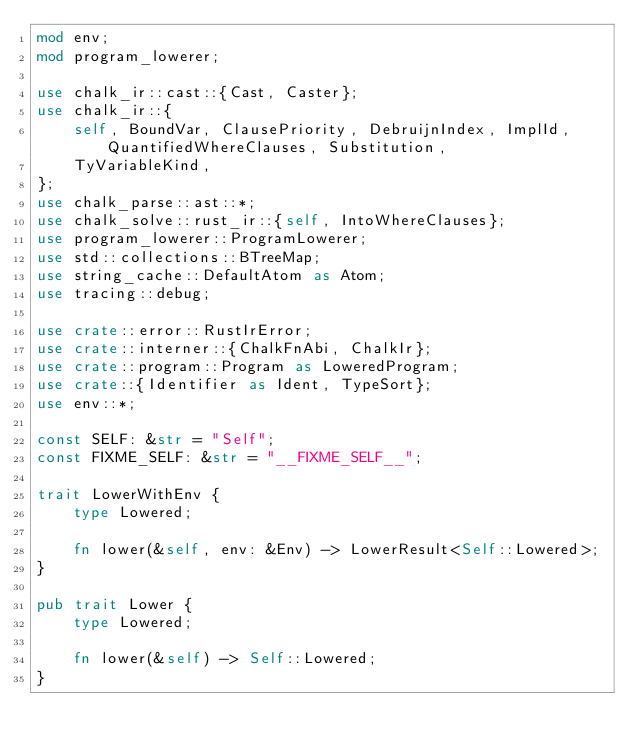Convert code to text. <code><loc_0><loc_0><loc_500><loc_500><_Rust_>mod env;
mod program_lowerer;

use chalk_ir::cast::{Cast, Caster};
use chalk_ir::{
    self, BoundVar, ClausePriority, DebruijnIndex, ImplId, QuantifiedWhereClauses, Substitution,
    TyVariableKind,
};
use chalk_parse::ast::*;
use chalk_solve::rust_ir::{self, IntoWhereClauses};
use program_lowerer::ProgramLowerer;
use std::collections::BTreeMap;
use string_cache::DefaultAtom as Atom;
use tracing::debug;

use crate::error::RustIrError;
use crate::interner::{ChalkFnAbi, ChalkIr};
use crate::program::Program as LoweredProgram;
use crate::{Identifier as Ident, TypeSort};
use env::*;

const SELF: &str = "Self";
const FIXME_SELF: &str = "__FIXME_SELF__";

trait LowerWithEnv {
    type Lowered;

    fn lower(&self, env: &Env) -> LowerResult<Self::Lowered>;
}

pub trait Lower {
    type Lowered;

    fn lower(&self) -> Self::Lowered;
}
</code> 